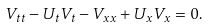<formula> <loc_0><loc_0><loc_500><loc_500>V _ { t t } - U _ { t } V _ { t } - V _ { x x } + U _ { x } V _ { x } = 0 .</formula> 